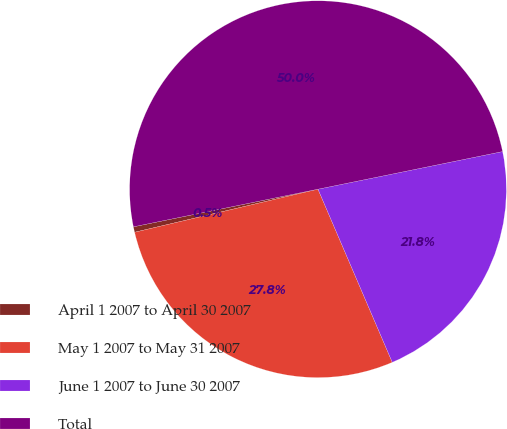Convert chart. <chart><loc_0><loc_0><loc_500><loc_500><pie_chart><fcel>April 1 2007 to April 30 2007<fcel>May 1 2007 to May 31 2007<fcel>June 1 2007 to June 30 2007<fcel>Total<nl><fcel>0.47%<fcel>27.78%<fcel>21.75%<fcel>50.0%<nl></chart> 